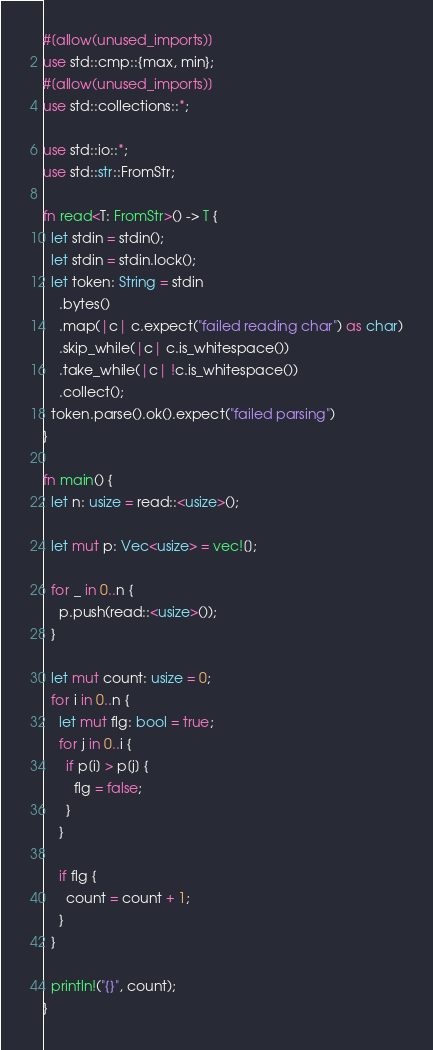Convert code to text. <code><loc_0><loc_0><loc_500><loc_500><_Rust_>#[allow(unused_imports)]
use std::cmp::{max, min};
#[allow(unused_imports)]
use std::collections::*;

use std::io::*;
use std::str::FromStr;

fn read<T: FromStr>() -> T {
  let stdin = stdin();
  let stdin = stdin.lock();
  let token: String = stdin
    .bytes()
    .map(|c| c.expect("failed reading char") as char)
    .skip_while(|c| c.is_whitespace())
    .take_while(|c| !c.is_whitespace())
    .collect();
  token.parse().ok().expect("failed parsing")
}

fn main() {
  let n: usize = read::<usize>();

  let mut p: Vec<usize> = vec![];

  for _ in 0..n {
    p.push(read::<usize>());
  }

  let mut count: usize = 0;
  for i in 0..n {
    let mut flg: bool = true;
    for j in 0..i {
      if p[i] > p[j] {
        flg = false;
      }
    }

    if flg {
      count = count + 1;
    }
  }

  println!("{}", count);
}
</code> 